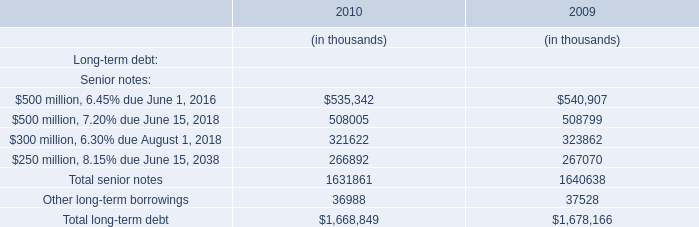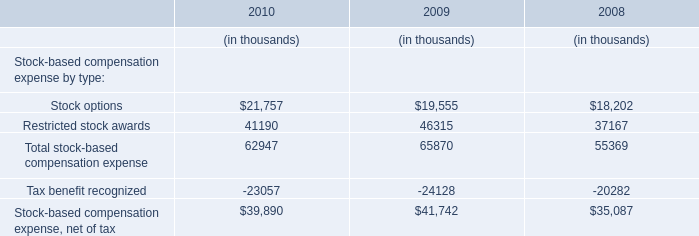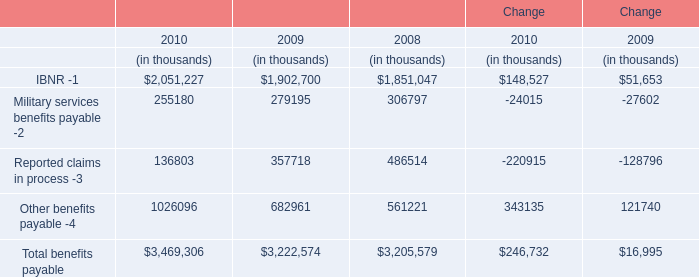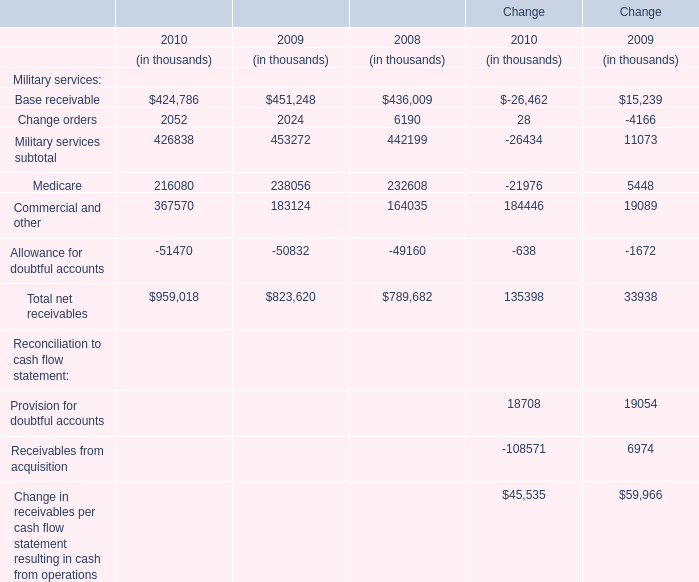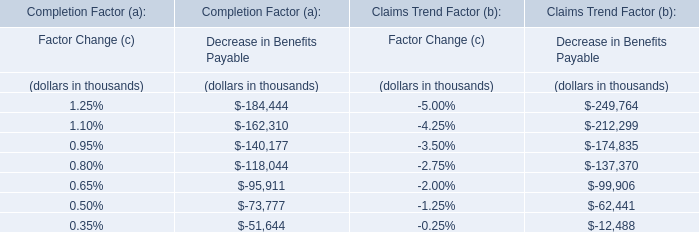Which element exceeds 10 % of total benefits payable in 2010? 
Answer: IBNR, Other benefits payable. 